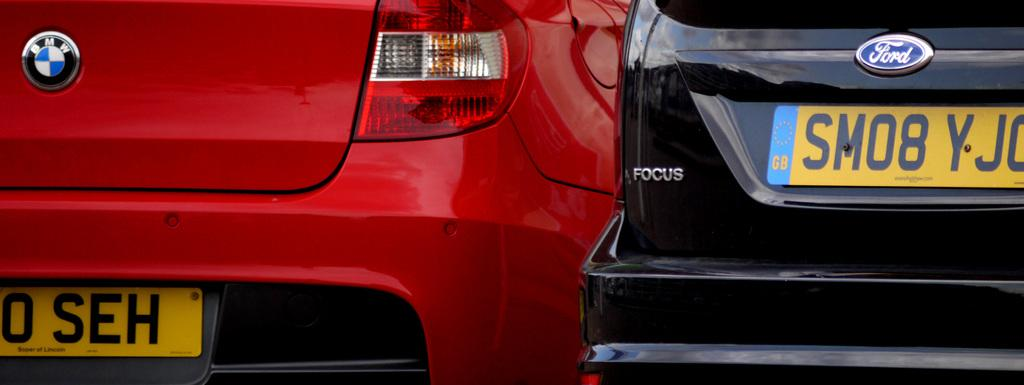How many cars are visible in the image? There are two cars in the image. What colors are the cars? One car is black, and the other car is red. Do the cars have any identifying features? Yes, both cars have number plates. What type of button is being pushed by the driver in the red car? There is no driver or button visible in the image; it only shows two parked cars. 